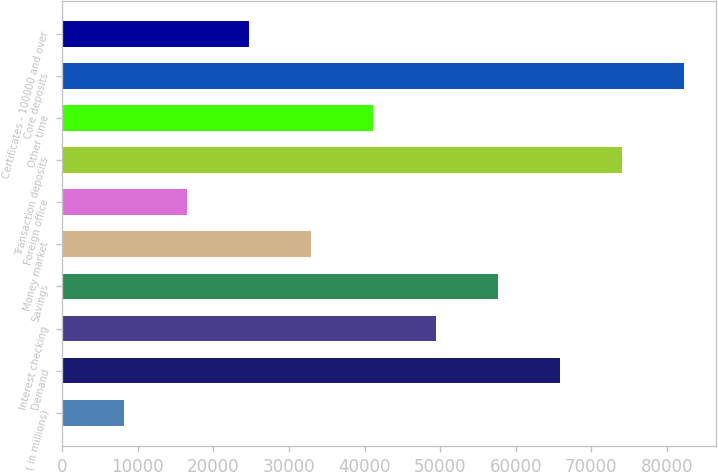Convert chart to OTSL. <chart><loc_0><loc_0><loc_500><loc_500><bar_chart><fcel>( in millions)<fcel>Demand<fcel>Interest checking<fcel>Savings<fcel>Money market<fcel>Foreign office<fcel>Transaction deposits<fcel>Other time<fcel>Core deposits<fcel>Certificates - 100000 and over<nl><fcel>8237.8<fcel>65853.4<fcel>49391.8<fcel>57622.6<fcel>32930.2<fcel>16468.6<fcel>74084.2<fcel>41161<fcel>82315<fcel>24699.4<nl></chart> 